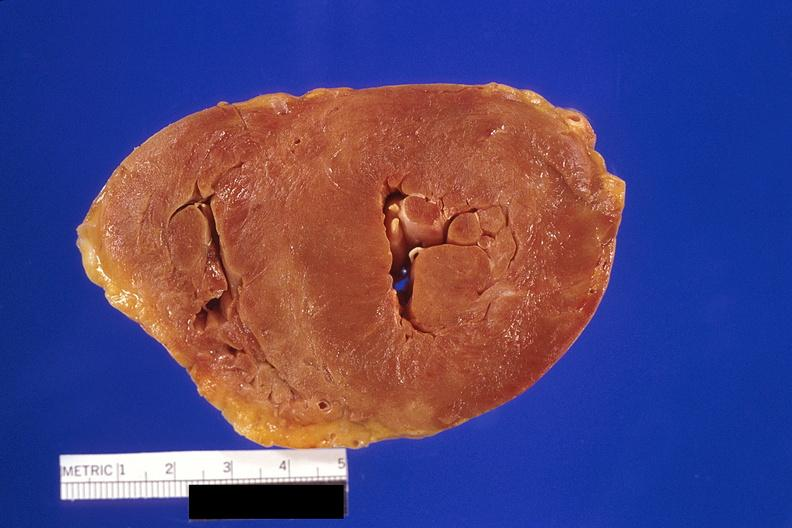how is amyloidosis left hypertrophy?
Answer the question using a single word or phrase. Ventricular 